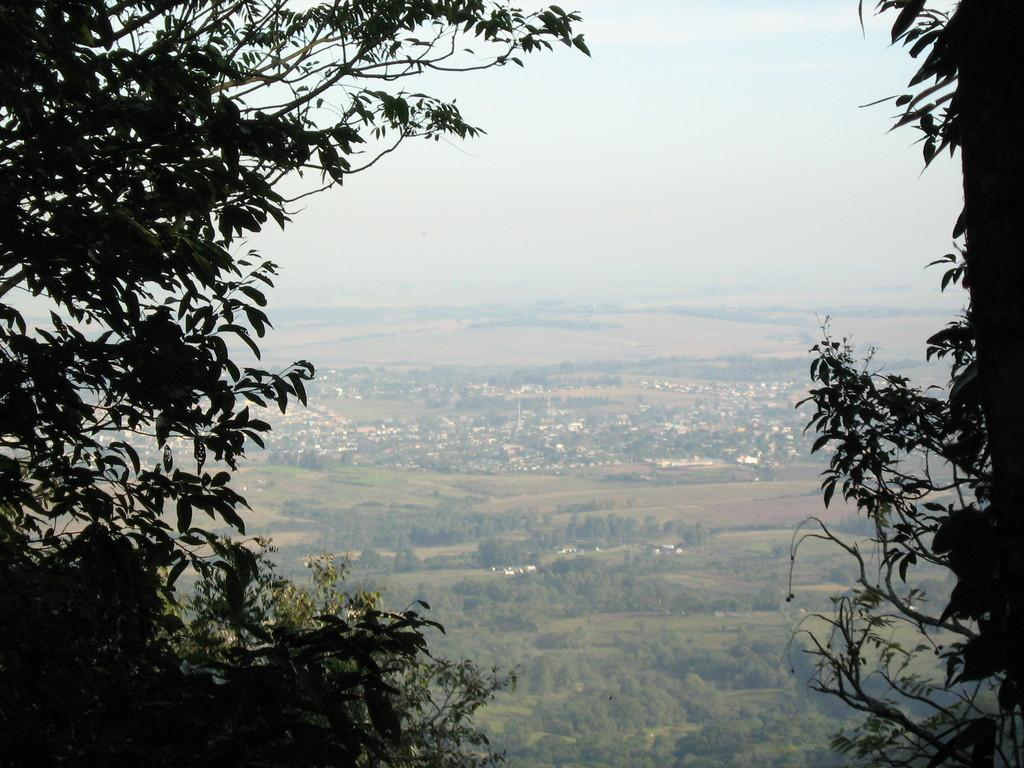What type of vegetation can be seen in the image? There are trees in the image. What color are the trees? The trees are green. What can be seen in the background of the image? There are buildings in the background of the image. What is visible in the sky in the image? The sky is visible in the image, and it is blue and white. Can you tell me how many tigers are swimming in the river in the image? There is no river or tiger present in the image; it features trees, buildings, and a blue and white sky. 